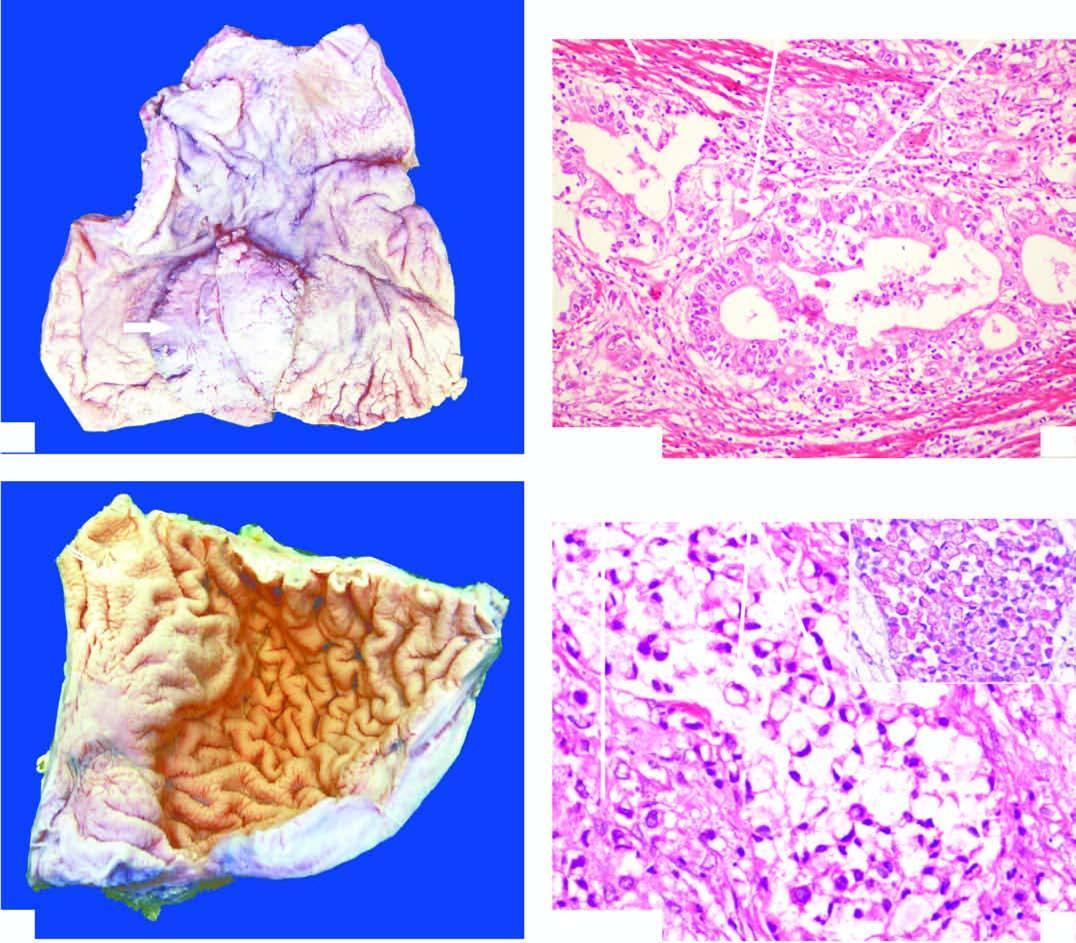does the mucosal fold?
Answer the question using a single word or phrase. Yes 